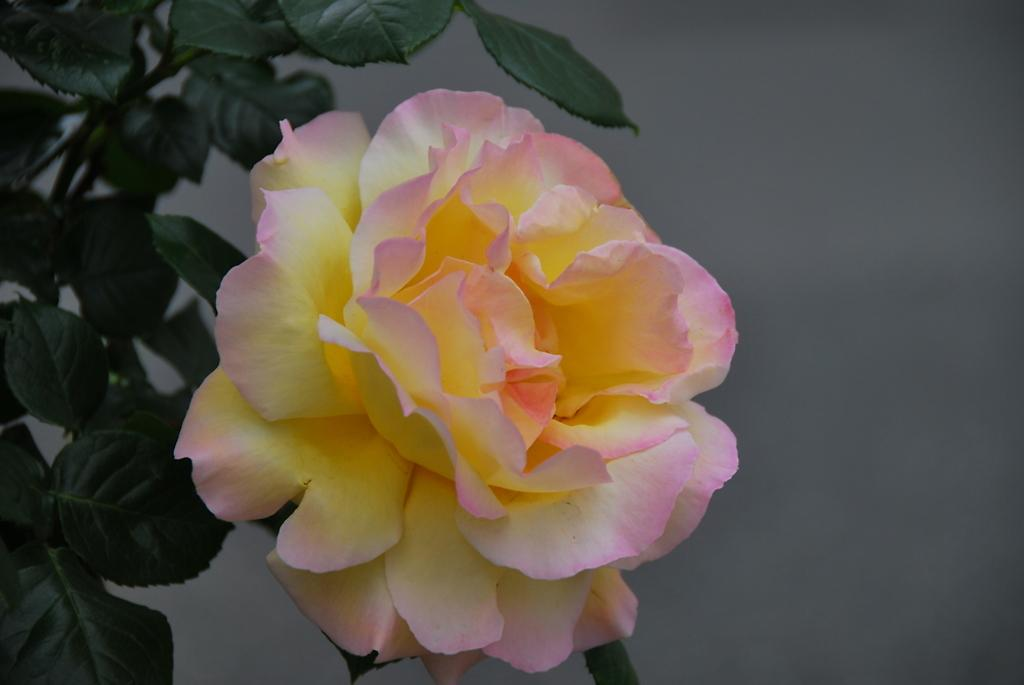What is the main subject of the image? There is a flower in the image. Can you describe the colors of the flower? The flower has yellow and pink colors. What else can be seen in the background of the image? There are leaves in the background of the image. How does the flower contribute to the digestion process in the image? There is no indication of a digestion process in the image, as it only features a flower and leaves. 